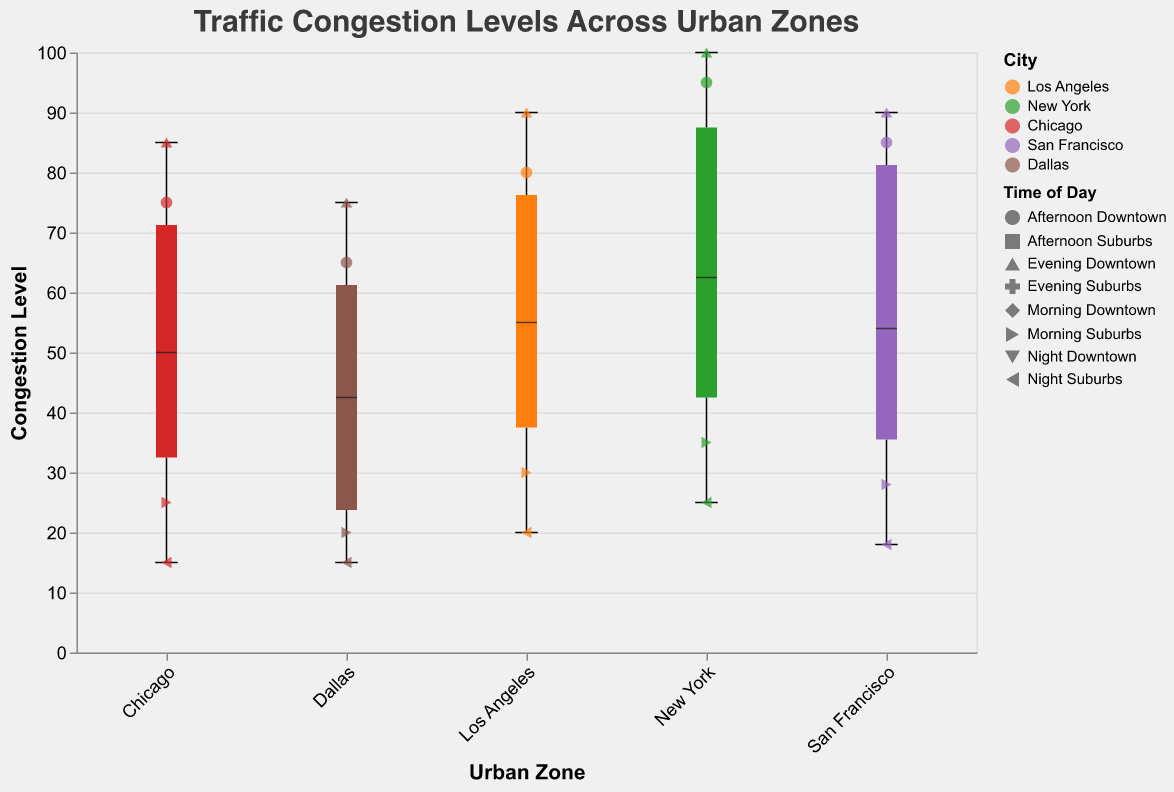What is the median congestion level for New York? To find the median congestion level for New York, observe the thick line within the boxplot of the New York category. This line represents the median value. Upon inspection, it is clear that the median line stands at around 60.
Answer: 60 What times of the day have the highest congestion levels in Downtown areas? From the scatter points in the plot, you can see that the highest congestion levels in Downtown areas are during the evening, with values reaching up to 100.
Answer: Evening Which urban zone has the lowest congestion level during the night? Look at the scatter points for the night time across different urban zones. The lowest congestion level during the night is observed in the suburbs of Chicago, with a value of 15.
Answer: Suburbs of Chicago How does the congestion level in the suburbs of Dallas in the afternoon compare to that in the suburbs of New York in the afternoon? Check the scatter points for the suburbs of both cities in the afternoon. The congestion level in the suburbs of Dallas in the afternoon is 25, whereas in New York, it is 45. Thus, New York has a higher congestion level.
Answer: Higher in New York What is the color used to represent San Francisco, and how does its suburban congestion level vary? The color representing San Francisco can be determined by checking the color legend. San Francisco is represented by a shaded purple color. The suburban congestion levels for San Francisco range from 18 to 58.
Answer: Purple; 18 to 58 Which urban zone shows the largest spread in congestion levels? The spread in congestion levels is indicated by the height of the boxplots and the range of the whiskers. New York shows the largest spread as its boxplot and whiskers cover a wider range of values from around 25 to 100.
Answer: New York How does the congestion level in Chicago's downtown areas change from morning to night? Look at the scatter points for Chicago's downtown area across different times of the day. The congestion levels change from 70 in the morning to 75 in the afternoon, then to 85 in the evening, and finally decrease to 45 at night.
Answer: Decreases from evening to night What's the overall trend in congestion levels from suburbs to downtown across all cities? By observing the boxplots and scatter points, there is a clear trend that congestion levels are generally higher in downtown areas compared to suburb areas for all cities.
Answer: Higher in downtown 